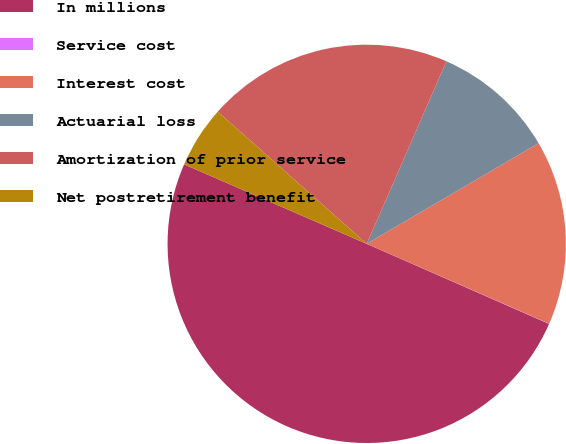Convert chart to OTSL. <chart><loc_0><loc_0><loc_500><loc_500><pie_chart><fcel>In millions<fcel>Service cost<fcel>Interest cost<fcel>Actuarial loss<fcel>Amortization of prior service<fcel>Net postretirement benefit<nl><fcel>49.95%<fcel>0.02%<fcel>15.0%<fcel>10.01%<fcel>20.0%<fcel>5.02%<nl></chart> 